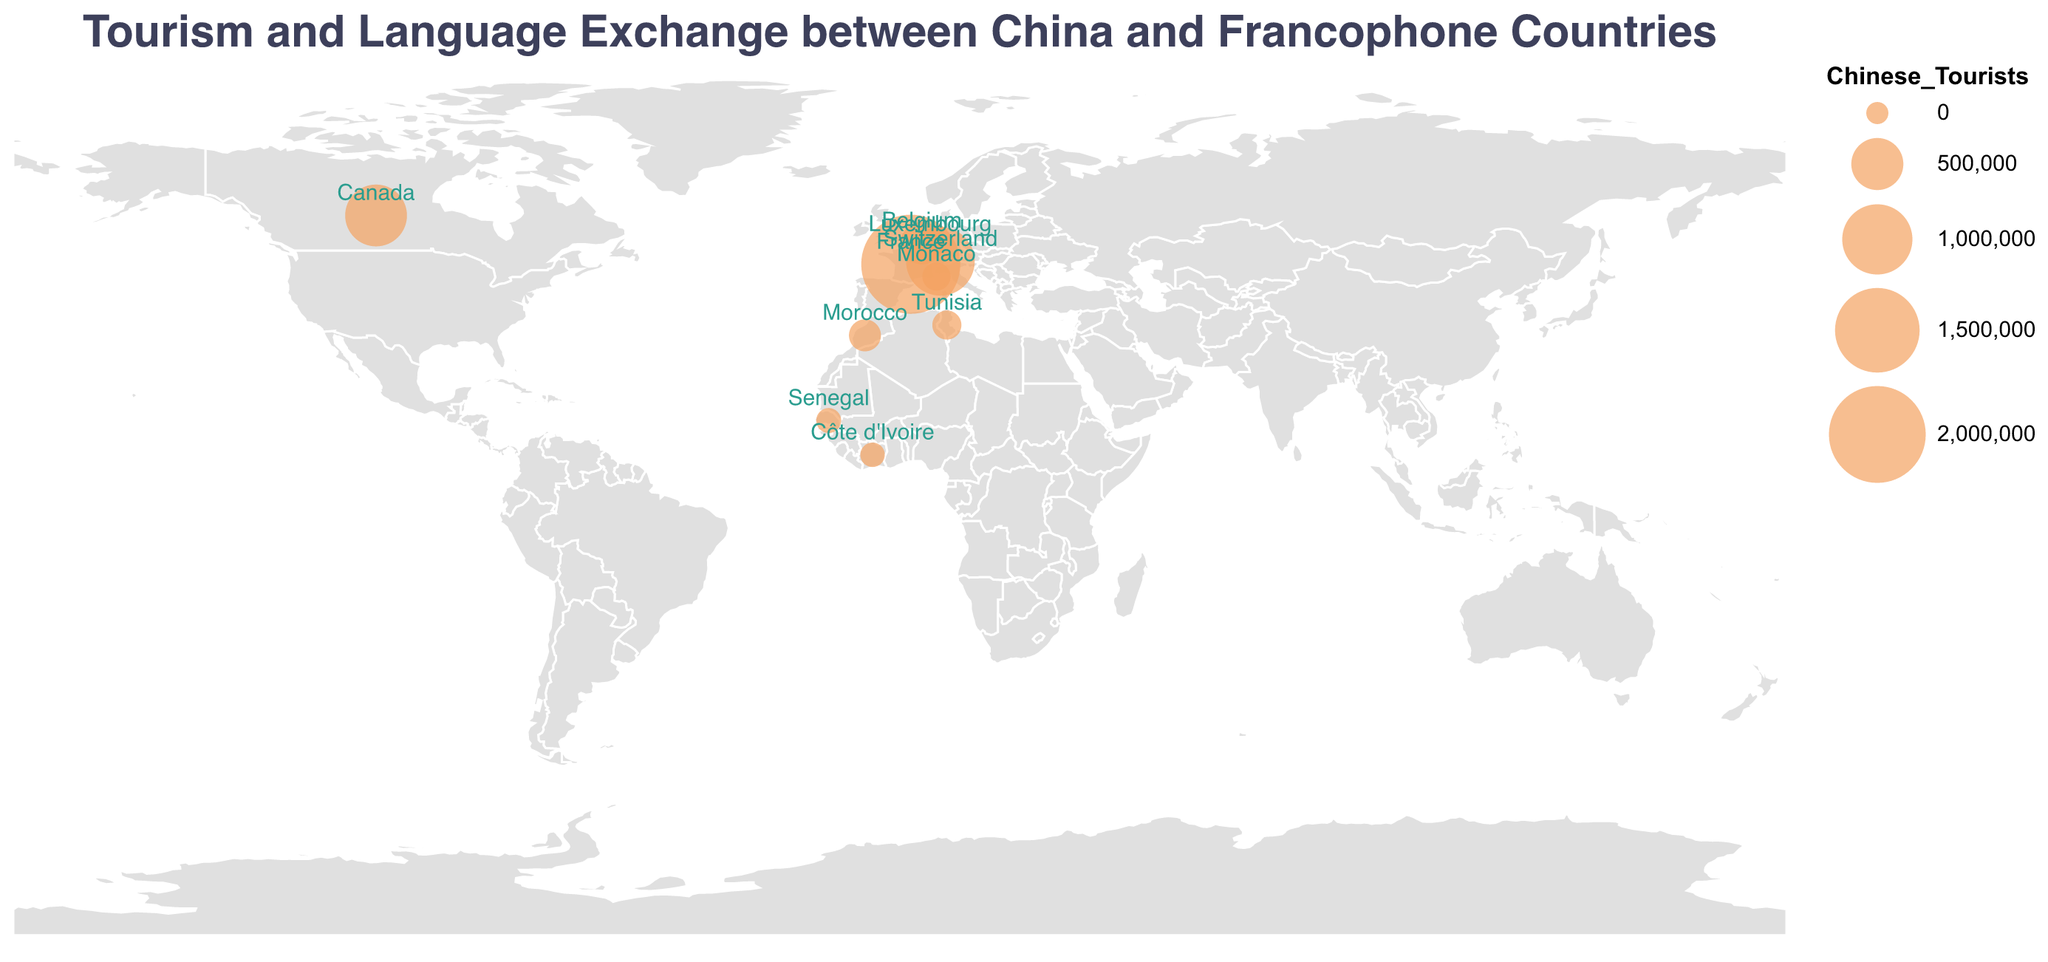What is the title of the figure? The title provides an overview of the theme or topic of the figure. It’s displayed prominently at the top of the figure.
Answer: "Tourism and Language Exchange between China and Francophone Countries" Which country has the largest number of Chinese tourists? We need to look at the size of the circles representing Chinese tourists in each country and identify the largest one.
Answer: France What is the total number of Chinese tourists visiting Belgium and Switzerland combined? Add the number of Chinese tourists visiting Belgium (300,000) and Switzerland (950,000) together: 300,000 + 950,000.
Answer: 1,250,000 Which country has the smallest number of bilateral exchanges with China? Compare the "Bilateral_Exchanges" values for each country, and identify the smallest value.
Answer: Monaco Out of the countries listed, which three have the highest number of French learners in China? Compare the "French_Learners" values for each country and select the three countries with the highest values.
Answer: France, Canada, Switzerland What is the difference in the number of Chinese tourists between France and Canada? Subtract the number of Chinese tourists in Canada (750,000) from the number in France (2,100,000): 2,100,000 - 750,000.
Answer: 1,350,000 Which country has more Chinese tourists: Belgium or Morocco? Compare the "Chinese_Tourists" values for Belgium (300,000) and Morocco (120,000).
Answer: Belgium What is the average number of French learners in China across all countries listed? Sum the number of French learners for all countries and then divide by the total number of countries (10): (150,000 + 80,000 + 25,000 + 40,000 + 15,000 + 10,000 + 5,000 + 4,000 + 3,000 + 2,000) / 10.
Answer: 33,400 Which country has the second-largest number of bilateral exchanges with China? Order the countries by their "Bilateral_Exchanges" value in descending order and find the second one.
Answer: Canada Are there more Chinese tourists visiting Monaco or Luxembourg? Compare the "Chinese_Tourists" values for Monaco (70,000) and Luxembourg (50,000).
Answer: Monaco 